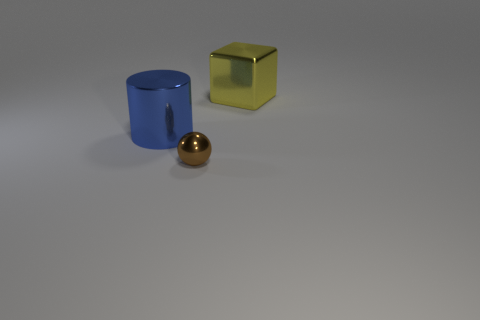Add 2 tiny brown spheres. How many objects exist? 5 Subtract all blocks. How many objects are left? 2 Subtract all yellow spheres. Subtract all big objects. How many objects are left? 1 Add 2 yellow things. How many yellow things are left? 3 Add 2 big cyan cylinders. How many big cyan cylinders exist? 2 Subtract 0 red balls. How many objects are left? 3 